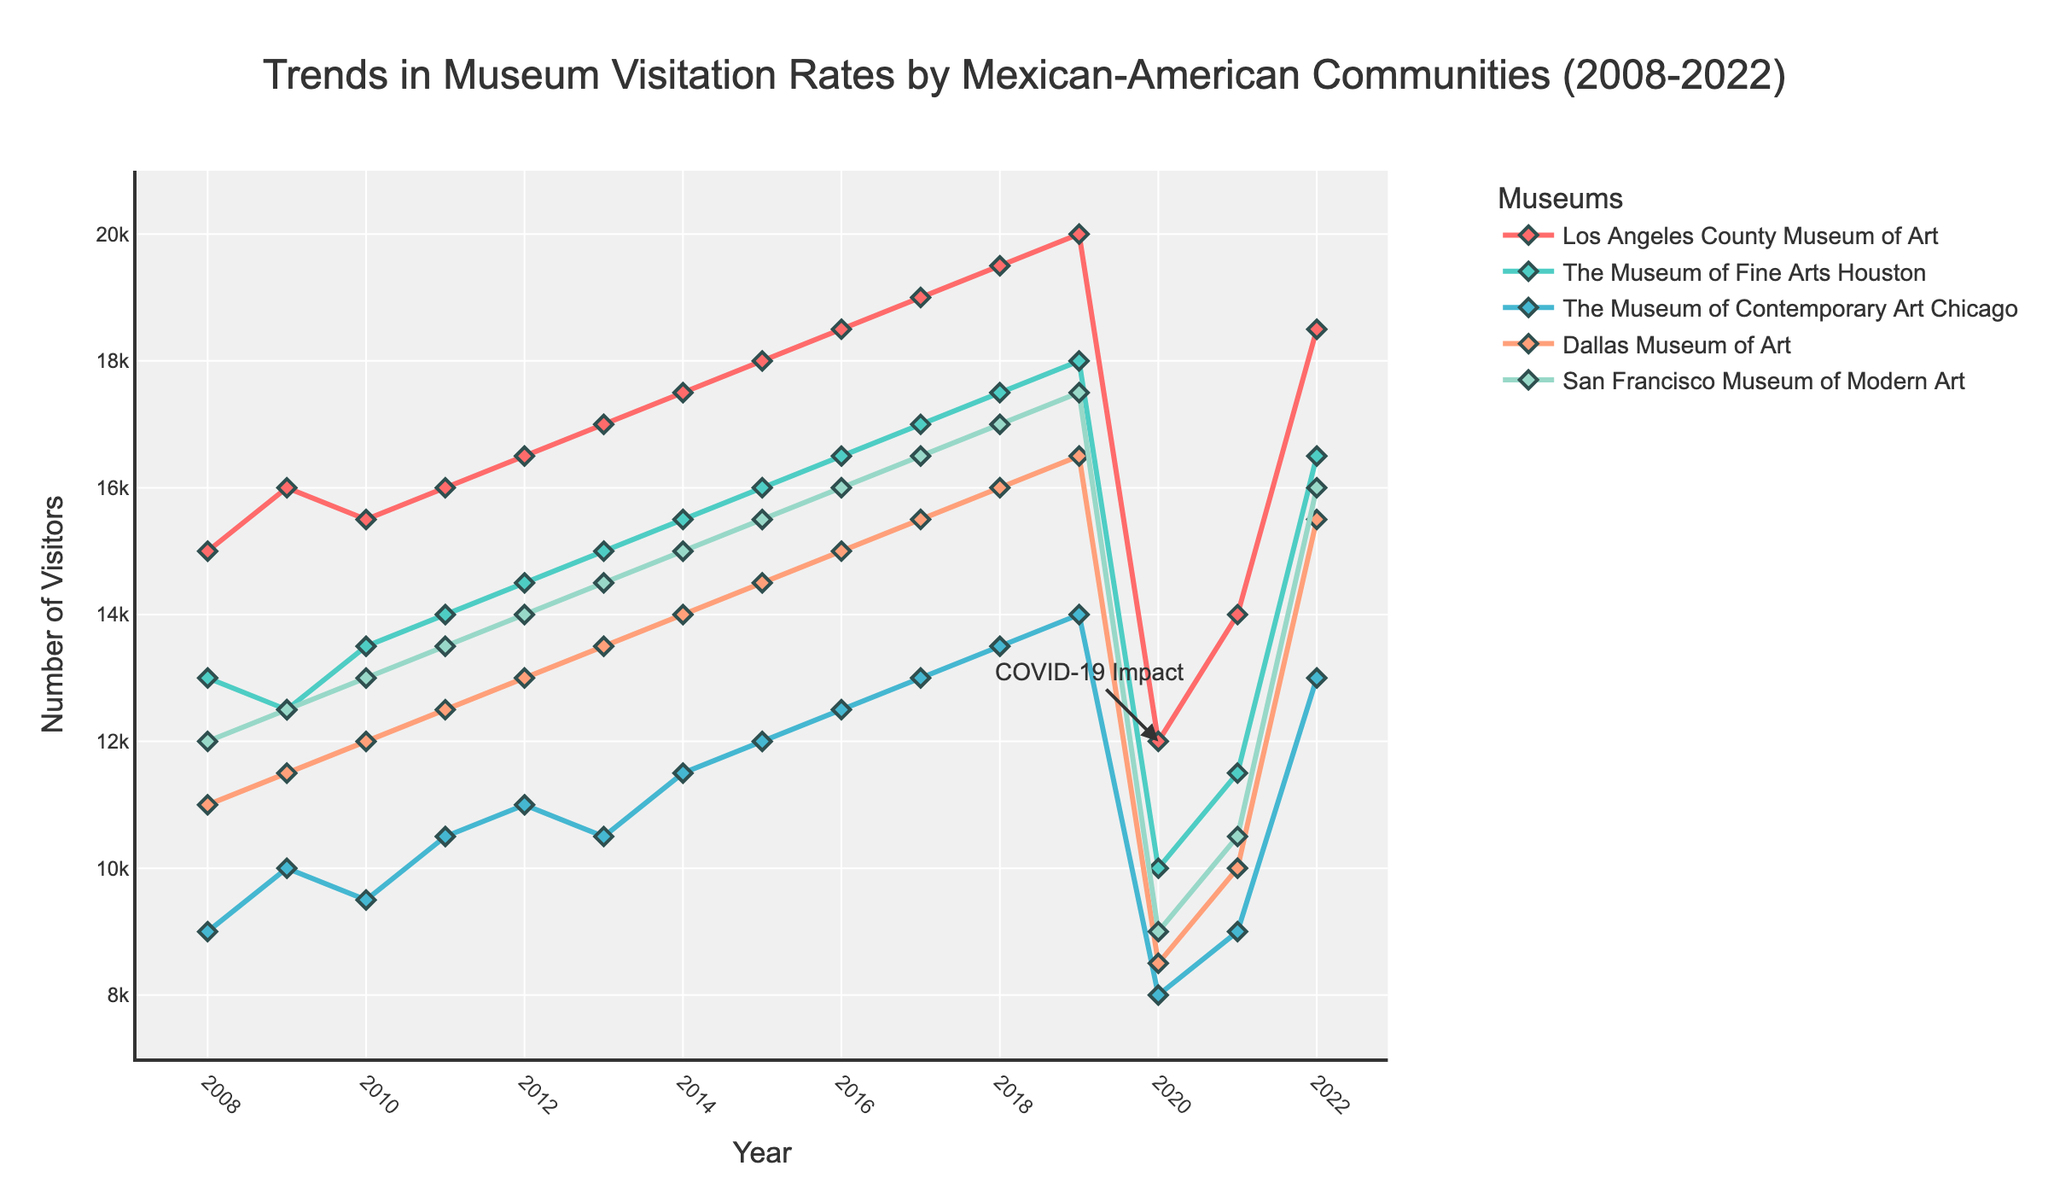What is the title of the figure? The title is usually at the top of the figure. In this case, the title reads "Trends in Museum Visitation Rates by Mexican-American Communities (2008-2022)".
Answer: Trends in Museum Visitation Rates by Mexican-American Communities (2008-2022) How many museums are shown in the figure? By examining the plot, you can see that there are five different traces, each corresponding to a different museum.
Answer: Five Which museum had the highest number of visitors in 2016? Look at the data points for each museum in 2016 and identify the highest value. The San Francisco Museum of Modern Art received 16,000 visitors, which is the highest.
Answer: San Francisco Museum of Modern Art What trend is seen in the visitation rates for all museums in 2020 and what might be the reason? All museums show a sharp decline in visitation rates in 2020. This is annotated with "COVID-19 Impact," indicating the pandemic's influence.
Answer: Sharp decline due to COVID-19 Compare the visitation rates of the Museum of Fine Arts Houston and the Dallas Museum of Art in 2022. Which one had more visitors and by how much? In 2022, the visitation rates are 16,500 for the Museum of Fine Arts Houston and 15,500 for the Dallas Museum of Art. Subtract to find the difference: 16,500 - 15,500 = 1,000.
Answer: Museum of Fine Arts Houston by 1,000 What's the average number of visitors for the Los Angeles County Museum of Art over the years 2008-2012? Summing up the visitation rates from 2008 to 2012: (15,000 + 16,000 + 15,500 + 16,000 + 16,500) = 79,000. Divide by 5 to find the average: 79,000 / 5 = 15,800.
Answer: 15,800 Between which two consecutive years did the Museum of Contemporary Art Chicago see the largest increase in visitors? To find the largest increase, subtract the previous year's data from the current year's data for each consecutive year: 2011-2010: 10500-9500 = 1000, 2012-2011: 11000-10500 = 500, and so on. The largest increase occurs between 2018 and 2019 (14,000 - 13,500 = 1,000).
Answer: 2018 to 2019 How did visitation rates for the Dallas Museum of Art change from 2019 to 2020? Compare the number of visitors in 2019 (16,500) and 2020 (8,500) and calculate the difference: 16,500 - 8,500 = 8,000. There is a sharp decrease.
Answer: Decreased by 8,000 Are visitation rates in 2022 higher or lower compared to 2019 for The Museum of Fine Arts Houston? Compare the visitation rates: 18,000 in 2019 vs. 16,500 in 2022. The latter is lower.
Answer: Lower 